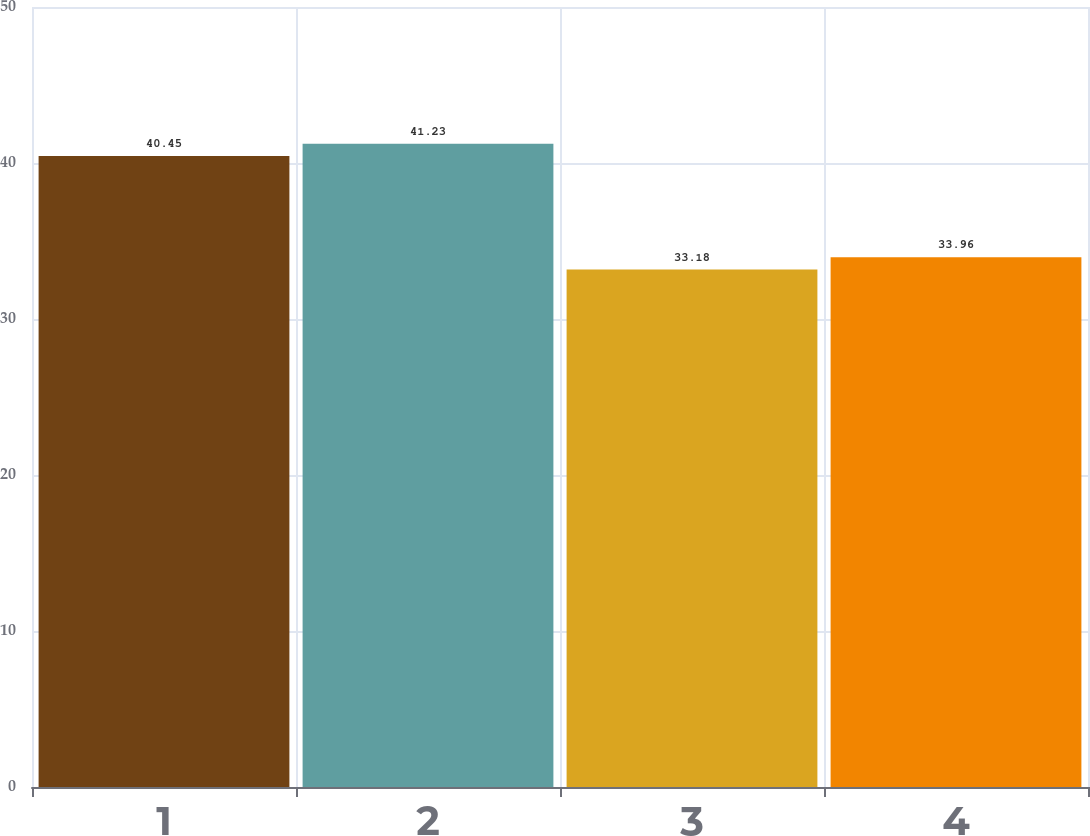Convert chart to OTSL. <chart><loc_0><loc_0><loc_500><loc_500><bar_chart><fcel>1<fcel>2<fcel>3<fcel>4<nl><fcel>40.45<fcel>41.23<fcel>33.18<fcel>33.96<nl></chart> 